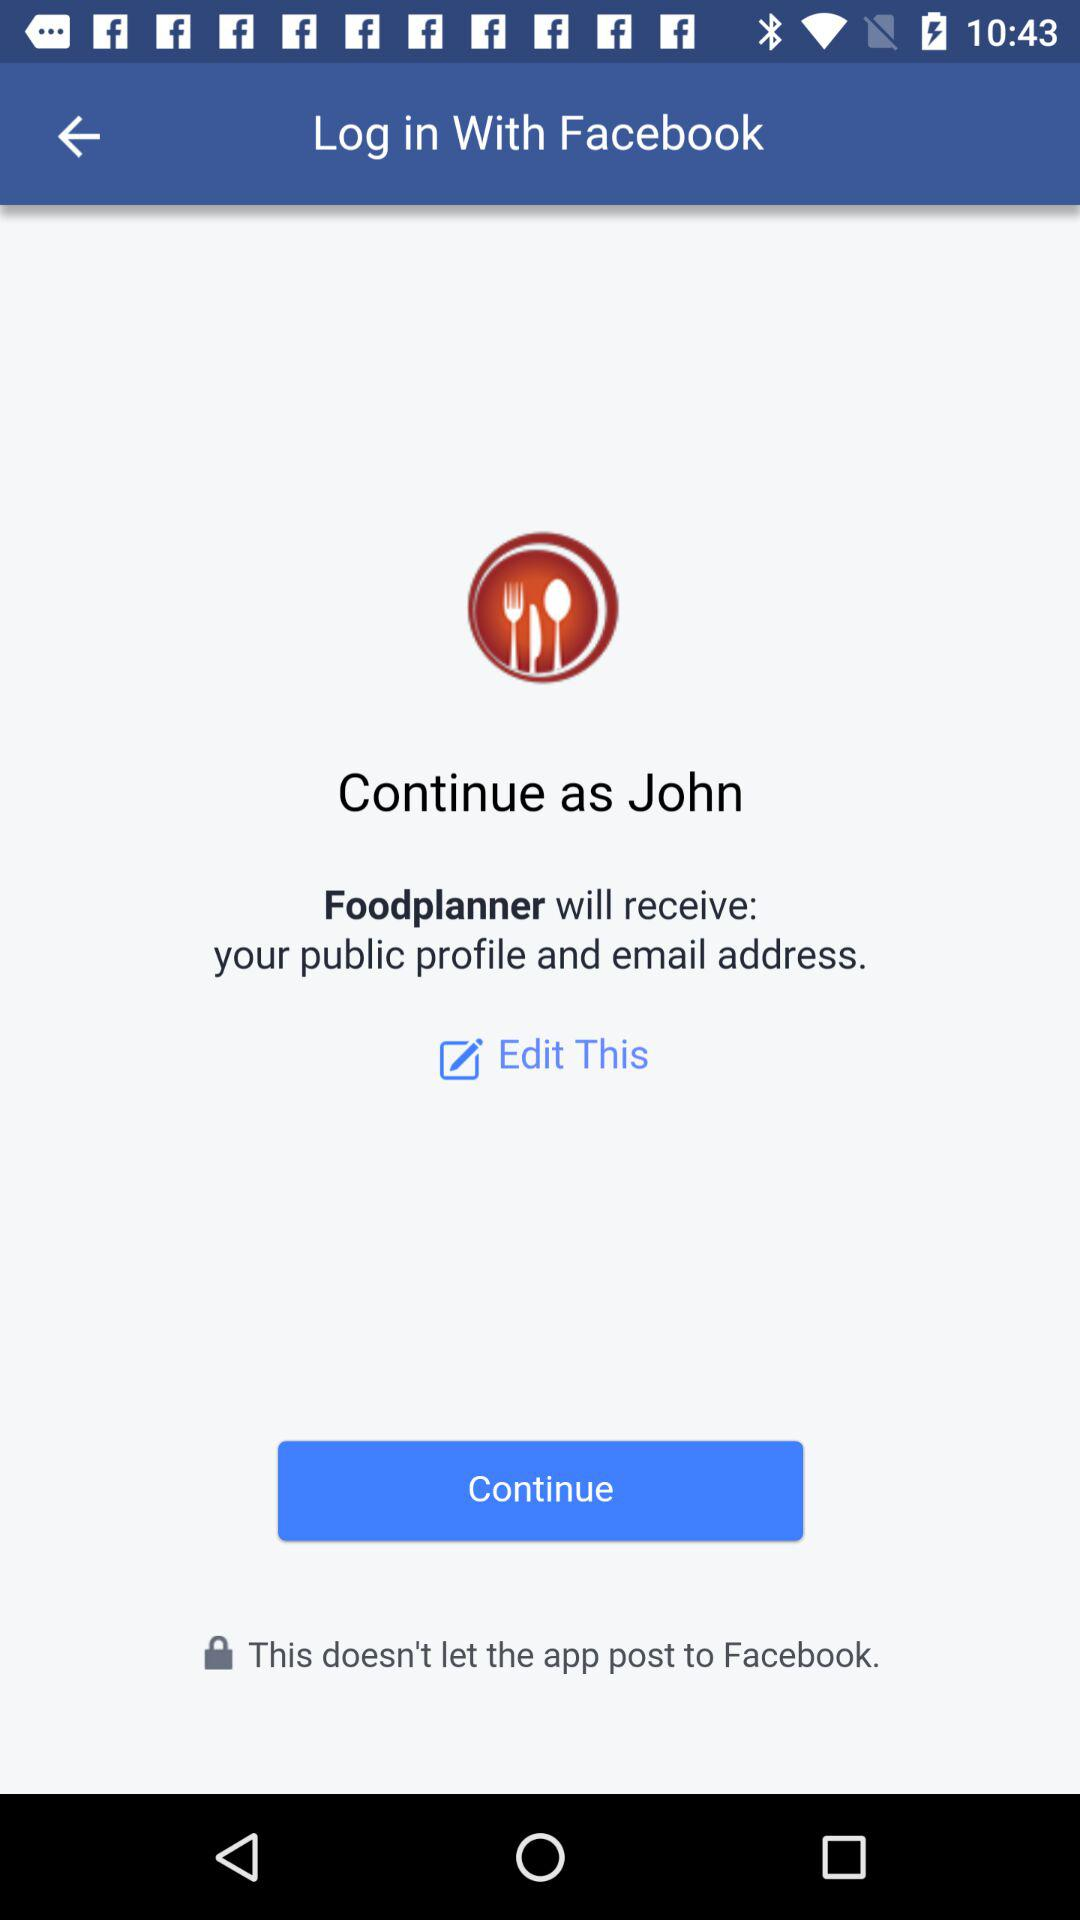What application will receive the public figure and email address? The application is "Foodplanner". 